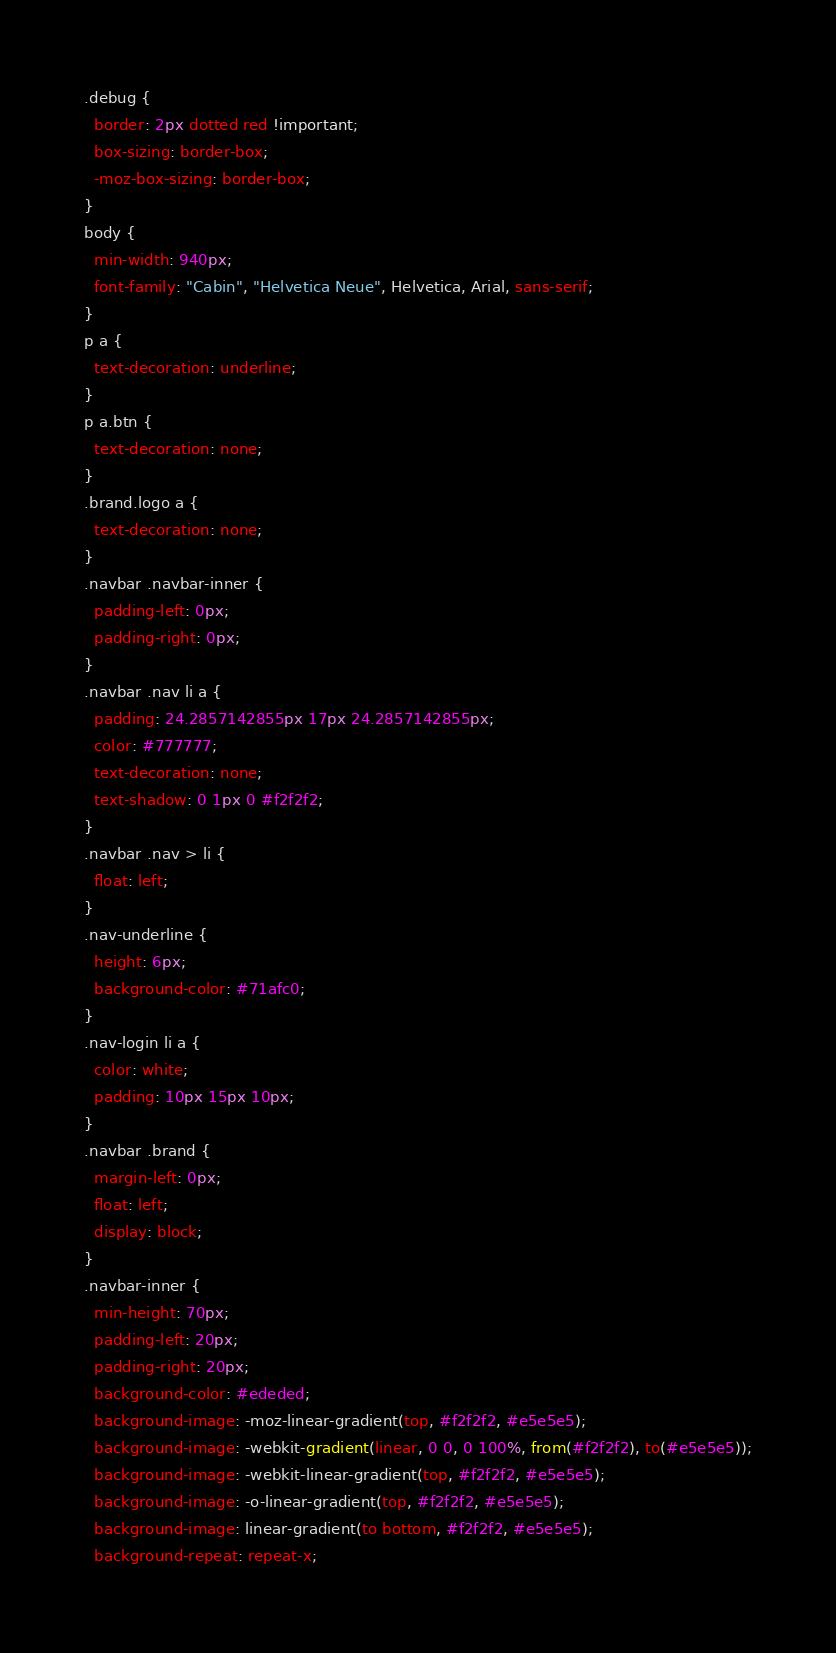<code> <loc_0><loc_0><loc_500><loc_500><_CSS_>.debug {
  border: 2px dotted red !important;
  box-sizing: border-box;
  -moz-box-sizing: border-box;
}
body {
  min-width: 940px;
  font-family: "Cabin", "Helvetica Neue", Helvetica, Arial, sans-serif;
}
p a {
  text-decoration: underline;
}
p a.btn {
  text-decoration: none;
}
.brand.logo a {
  text-decoration: none;
}
.navbar .navbar-inner {
  padding-left: 0px;
  padding-right: 0px;
}
.navbar .nav li a {
  padding: 24.2857142855px 17px 24.2857142855px;
  color: #777777;
  text-decoration: none;
  text-shadow: 0 1px 0 #f2f2f2;
}
.navbar .nav > li {
  float: left;
}
.nav-underline {
  height: 6px;
  background-color: #71afc0;
}
.nav-login li a {
  color: white;
  padding: 10px 15px 10px;
}
.navbar .brand {
  margin-left: 0px;
  float: left;
  display: block;
}
.navbar-inner {
  min-height: 70px;
  padding-left: 20px;
  padding-right: 20px;
  background-color: #ededed;
  background-image: -moz-linear-gradient(top, #f2f2f2, #e5e5e5);
  background-image: -webkit-gradient(linear, 0 0, 0 100%, from(#f2f2f2), to(#e5e5e5));
  background-image: -webkit-linear-gradient(top, #f2f2f2, #e5e5e5);
  background-image: -o-linear-gradient(top, #f2f2f2, #e5e5e5);
  background-image: linear-gradient(to bottom, #f2f2f2, #e5e5e5);
  background-repeat: repeat-x;</code> 